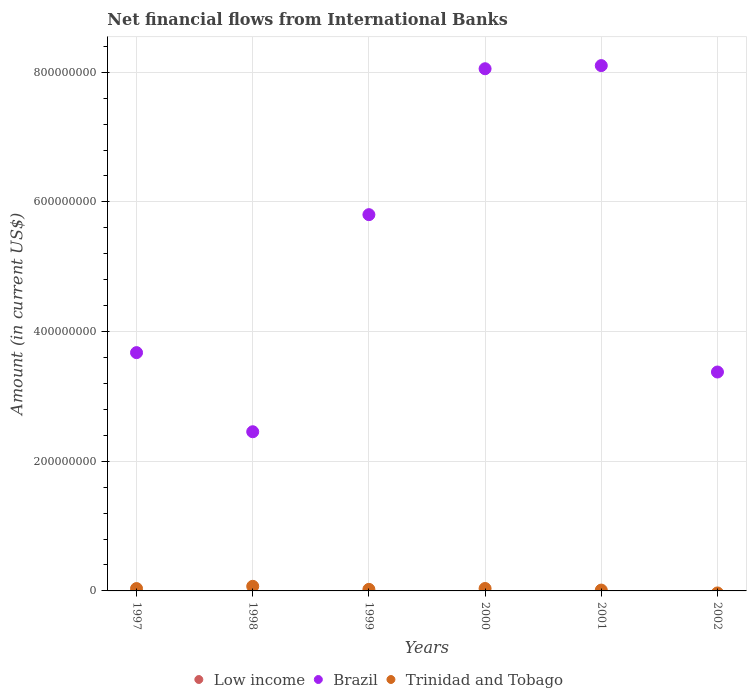What is the net financial aid flows in Brazil in 2002?
Your answer should be very brief. 3.38e+08. Across all years, what is the maximum net financial aid flows in Brazil?
Provide a short and direct response. 8.10e+08. Across all years, what is the minimum net financial aid flows in Low income?
Keep it short and to the point. 0. In which year was the net financial aid flows in Brazil maximum?
Provide a short and direct response. 2001. What is the total net financial aid flows in Trinidad and Tobago in the graph?
Provide a short and direct response. 1.82e+07. What is the difference between the net financial aid flows in Brazil in 1997 and that in 2001?
Offer a terse response. -4.43e+08. What is the difference between the net financial aid flows in Brazil in 2002 and the net financial aid flows in Trinidad and Tobago in 1997?
Provide a succinct answer. 3.34e+08. In the year 1998, what is the difference between the net financial aid flows in Brazil and net financial aid flows in Trinidad and Tobago?
Provide a short and direct response. 2.38e+08. What is the ratio of the net financial aid flows in Brazil in 2001 to that in 2002?
Your response must be concise. 2.4. Is the difference between the net financial aid flows in Brazil in 1998 and 1999 greater than the difference between the net financial aid flows in Trinidad and Tobago in 1998 and 1999?
Keep it short and to the point. No. What is the difference between the highest and the second highest net financial aid flows in Trinidad and Tobago?
Provide a short and direct response. 3.33e+06. What is the difference between the highest and the lowest net financial aid flows in Brazil?
Ensure brevity in your answer.  5.65e+08. Is the sum of the net financial aid flows in Trinidad and Tobago in 1997 and 2001 greater than the maximum net financial aid flows in Brazil across all years?
Provide a short and direct response. No. Does the net financial aid flows in Trinidad and Tobago monotonically increase over the years?
Ensure brevity in your answer.  No. Is the net financial aid flows in Brazil strictly less than the net financial aid flows in Low income over the years?
Make the answer very short. No. Does the graph contain any zero values?
Your answer should be compact. Yes. How are the legend labels stacked?
Ensure brevity in your answer.  Horizontal. What is the title of the graph?
Ensure brevity in your answer.  Net financial flows from International Banks. Does "Ireland" appear as one of the legend labels in the graph?
Your answer should be very brief. No. What is the label or title of the X-axis?
Ensure brevity in your answer.  Years. What is the label or title of the Y-axis?
Offer a terse response. Amount (in current US$). What is the Amount (in current US$) in Brazil in 1997?
Provide a succinct answer. 3.68e+08. What is the Amount (in current US$) of Trinidad and Tobago in 1997?
Provide a succinct answer. 3.64e+06. What is the Amount (in current US$) in Low income in 1998?
Your answer should be compact. 0. What is the Amount (in current US$) in Brazil in 1998?
Offer a terse response. 2.46e+08. What is the Amount (in current US$) of Trinidad and Tobago in 1998?
Offer a very short reply. 7.10e+06. What is the Amount (in current US$) in Brazil in 1999?
Your answer should be very brief. 5.80e+08. What is the Amount (in current US$) of Trinidad and Tobago in 1999?
Offer a terse response. 2.40e+06. What is the Amount (in current US$) of Brazil in 2000?
Offer a terse response. 8.05e+08. What is the Amount (in current US$) in Trinidad and Tobago in 2000?
Provide a succinct answer. 3.76e+06. What is the Amount (in current US$) in Low income in 2001?
Provide a succinct answer. 0. What is the Amount (in current US$) in Brazil in 2001?
Your answer should be very brief. 8.10e+08. What is the Amount (in current US$) of Trinidad and Tobago in 2001?
Offer a very short reply. 1.28e+06. What is the Amount (in current US$) in Brazil in 2002?
Keep it short and to the point. 3.38e+08. Across all years, what is the maximum Amount (in current US$) in Brazil?
Give a very brief answer. 8.10e+08. Across all years, what is the maximum Amount (in current US$) of Trinidad and Tobago?
Provide a succinct answer. 7.10e+06. Across all years, what is the minimum Amount (in current US$) in Brazil?
Provide a succinct answer. 2.46e+08. Across all years, what is the minimum Amount (in current US$) in Trinidad and Tobago?
Your answer should be very brief. 0. What is the total Amount (in current US$) in Low income in the graph?
Give a very brief answer. 0. What is the total Amount (in current US$) in Brazil in the graph?
Ensure brevity in your answer.  3.15e+09. What is the total Amount (in current US$) in Trinidad and Tobago in the graph?
Your answer should be very brief. 1.82e+07. What is the difference between the Amount (in current US$) in Brazil in 1997 and that in 1998?
Your answer should be very brief. 1.22e+08. What is the difference between the Amount (in current US$) of Trinidad and Tobago in 1997 and that in 1998?
Make the answer very short. -3.46e+06. What is the difference between the Amount (in current US$) in Brazil in 1997 and that in 1999?
Give a very brief answer. -2.13e+08. What is the difference between the Amount (in current US$) of Trinidad and Tobago in 1997 and that in 1999?
Make the answer very short. 1.23e+06. What is the difference between the Amount (in current US$) of Brazil in 1997 and that in 2000?
Ensure brevity in your answer.  -4.38e+08. What is the difference between the Amount (in current US$) in Trinidad and Tobago in 1997 and that in 2000?
Your response must be concise. -1.28e+05. What is the difference between the Amount (in current US$) in Brazil in 1997 and that in 2001?
Make the answer very short. -4.43e+08. What is the difference between the Amount (in current US$) in Trinidad and Tobago in 1997 and that in 2001?
Keep it short and to the point. 2.35e+06. What is the difference between the Amount (in current US$) of Brazil in 1997 and that in 2002?
Provide a succinct answer. 2.99e+07. What is the difference between the Amount (in current US$) of Brazil in 1998 and that in 1999?
Ensure brevity in your answer.  -3.35e+08. What is the difference between the Amount (in current US$) of Trinidad and Tobago in 1998 and that in 1999?
Make the answer very short. 4.69e+06. What is the difference between the Amount (in current US$) in Brazil in 1998 and that in 2000?
Offer a terse response. -5.60e+08. What is the difference between the Amount (in current US$) in Trinidad and Tobago in 1998 and that in 2000?
Give a very brief answer. 3.33e+06. What is the difference between the Amount (in current US$) in Brazil in 1998 and that in 2001?
Provide a short and direct response. -5.65e+08. What is the difference between the Amount (in current US$) of Trinidad and Tobago in 1998 and that in 2001?
Give a very brief answer. 5.82e+06. What is the difference between the Amount (in current US$) of Brazil in 1998 and that in 2002?
Ensure brevity in your answer.  -9.21e+07. What is the difference between the Amount (in current US$) in Brazil in 1999 and that in 2000?
Give a very brief answer. -2.25e+08. What is the difference between the Amount (in current US$) of Trinidad and Tobago in 1999 and that in 2000?
Your response must be concise. -1.36e+06. What is the difference between the Amount (in current US$) in Brazil in 1999 and that in 2001?
Give a very brief answer. -2.30e+08. What is the difference between the Amount (in current US$) of Trinidad and Tobago in 1999 and that in 2001?
Give a very brief answer. 1.12e+06. What is the difference between the Amount (in current US$) of Brazil in 1999 and that in 2002?
Provide a succinct answer. 2.43e+08. What is the difference between the Amount (in current US$) of Brazil in 2000 and that in 2001?
Your response must be concise. -4.84e+06. What is the difference between the Amount (in current US$) of Trinidad and Tobago in 2000 and that in 2001?
Keep it short and to the point. 2.48e+06. What is the difference between the Amount (in current US$) in Brazil in 2000 and that in 2002?
Provide a succinct answer. 4.68e+08. What is the difference between the Amount (in current US$) in Brazil in 2001 and that in 2002?
Provide a succinct answer. 4.73e+08. What is the difference between the Amount (in current US$) in Brazil in 1997 and the Amount (in current US$) in Trinidad and Tobago in 1998?
Provide a short and direct response. 3.60e+08. What is the difference between the Amount (in current US$) of Brazil in 1997 and the Amount (in current US$) of Trinidad and Tobago in 1999?
Ensure brevity in your answer.  3.65e+08. What is the difference between the Amount (in current US$) in Brazil in 1997 and the Amount (in current US$) in Trinidad and Tobago in 2000?
Your response must be concise. 3.64e+08. What is the difference between the Amount (in current US$) of Brazil in 1997 and the Amount (in current US$) of Trinidad and Tobago in 2001?
Your response must be concise. 3.66e+08. What is the difference between the Amount (in current US$) in Brazil in 1998 and the Amount (in current US$) in Trinidad and Tobago in 1999?
Make the answer very short. 2.43e+08. What is the difference between the Amount (in current US$) in Brazil in 1998 and the Amount (in current US$) in Trinidad and Tobago in 2000?
Offer a terse response. 2.42e+08. What is the difference between the Amount (in current US$) of Brazil in 1998 and the Amount (in current US$) of Trinidad and Tobago in 2001?
Provide a succinct answer. 2.44e+08. What is the difference between the Amount (in current US$) of Brazil in 1999 and the Amount (in current US$) of Trinidad and Tobago in 2000?
Give a very brief answer. 5.77e+08. What is the difference between the Amount (in current US$) of Brazil in 1999 and the Amount (in current US$) of Trinidad and Tobago in 2001?
Give a very brief answer. 5.79e+08. What is the difference between the Amount (in current US$) of Brazil in 2000 and the Amount (in current US$) of Trinidad and Tobago in 2001?
Give a very brief answer. 8.04e+08. What is the average Amount (in current US$) of Low income per year?
Give a very brief answer. 0. What is the average Amount (in current US$) of Brazil per year?
Offer a very short reply. 5.24e+08. What is the average Amount (in current US$) of Trinidad and Tobago per year?
Your answer should be very brief. 3.03e+06. In the year 1997, what is the difference between the Amount (in current US$) in Brazil and Amount (in current US$) in Trinidad and Tobago?
Offer a very short reply. 3.64e+08. In the year 1998, what is the difference between the Amount (in current US$) in Brazil and Amount (in current US$) in Trinidad and Tobago?
Your response must be concise. 2.38e+08. In the year 1999, what is the difference between the Amount (in current US$) of Brazil and Amount (in current US$) of Trinidad and Tobago?
Ensure brevity in your answer.  5.78e+08. In the year 2000, what is the difference between the Amount (in current US$) of Brazil and Amount (in current US$) of Trinidad and Tobago?
Keep it short and to the point. 8.02e+08. In the year 2001, what is the difference between the Amount (in current US$) in Brazil and Amount (in current US$) in Trinidad and Tobago?
Ensure brevity in your answer.  8.09e+08. What is the ratio of the Amount (in current US$) in Brazil in 1997 to that in 1998?
Give a very brief answer. 1.5. What is the ratio of the Amount (in current US$) of Trinidad and Tobago in 1997 to that in 1998?
Your answer should be compact. 0.51. What is the ratio of the Amount (in current US$) in Brazil in 1997 to that in 1999?
Provide a succinct answer. 0.63. What is the ratio of the Amount (in current US$) of Trinidad and Tobago in 1997 to that in 1999?
Provide a succinct answer. 1.51. What is the ratio of the Amount (in current US$) of Brazil in 1997 to that in 2000?
Provide a succinct answer. 0.46. What is the ratio of the Amount (in current US$) in Trinidad and Tobago in 1997 to that in 2000?
Keep it short and to the point. 0.97. What is the ratio of the Amount (in current US$) in Brazil in 1997 to that in 2001?
Your answer should be very brief. 0.45. What is the ratio of the Amount (in current US$) in Trinidad and Tobago in 1997 to that in 2001?
Offer a terse response. 2.84. What is the ratio of the Amount (in current US$) in Brazil in 1997 to that in 2002?
Make the answer very short. 1.09. What is the ratio of the Amount (in current US$) in Brazil in 1998 to that in 1999?
Make the answer very short. 0.42. What is the ratio of the Amount (in current US$) of Trinidad and Tobago in 1998 to that in 1999?
Ensure brevity in your answer.  2.95. What is the ratio of the Amount (in current US$) in Brazil in 1998 to that in 2000?
Ensure brevity in your answer.  0.3. What is the ratio of the Amount (in current US$) of Trinidad and Tobago in 1998 to that in 2000?
Offer a very short reply. 1.89. What is the ratio of the Amount (in current US$) of Brazil in 1998 to that in 2001?
Make the answer very short. 0.3. What is the ratio of the Amount (in current US$) in Trinidad and Tobago in 1998 to that in 2001?
Your response must be concise. 5.54. What is the ratio of the Amount (in current US$) in Brazil in 1998 to that in 2002?
Make the answer very short. 0.73. What is the ratio of the Amount (in current US$) of Brazil in 1999 to that in 2000?
Make the answer very short. 0.72. What is the ratio of the Amount (in current US$) in Trinidad and Tobago in 1999 to that in 2000?
Give a very brief answer. 0.64. What is the ratio of the Amount (in current US$) in Brazil in 1999 to that in 2001?
Keep it short and to the point. 0.72. What is the ratio of the Amount (in current US$) of Trinidad and Tobago in 1999 to that in 2001?
Give a very brief answer. 1.87. What is the ratio of the Amount (in current US$) of Brazil in 1999 to that in 2002?
Your answer should be very brief. 1.72. What is the ratio of the Amount (in current US$) in Brazil in 2000 to that in 2001?
Your answer should be compact. 0.99. What is the ratio of the Amount (in current US$) in Trinidad and Tobago in 2000 to that in 2001?
Provide a succinct answer. 2.94. What is the ratio of the Amount (in current US$) in Brazil in 2000 to that in 2002?
Your answer should be very brief. 2.39. What is the ratio of the Amount (in current US$) in Brazil in 2001 to that in 2002?
Ensure brevity in your answer.  2.4. What is the difference between the highest and the second highest Amount (in current US$) in Brazil?
Provide a short and direct response. 4.84e+06. What is the difference between the highest and the second highest Amount (in current US$) in Trinidad and Tobago?
Give a very brief answer. 3.33e+06. What is the difference between the highest and the lowest Amount (in current US$) of Brazil?
Provide a succinct answer. 5.65e+08. What is the difference between the highest and the lowest Amount (in current US$) of Trinidad and Tobago?
Offer a terse response. 7.10e+06. 